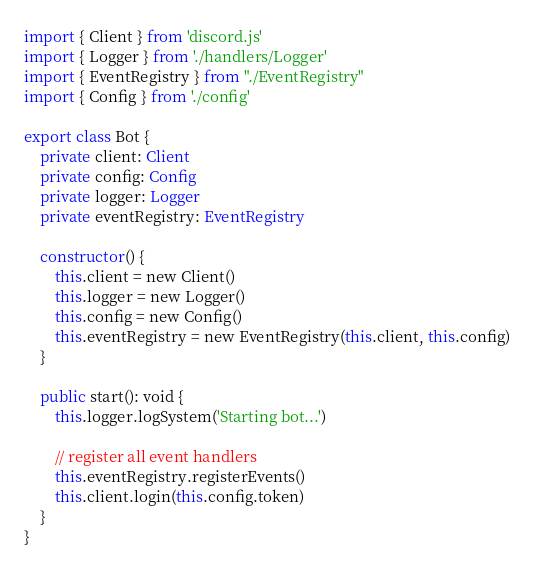Convert code to text. <code><loc_0><loc_0><loc_500><loc_500><_TypeScript_>import { Client } from 'discord.js'
import { Logger } from './handlers/Logger'
import { EventRegistry } from "./EventRegistry"
import { Config } from './config'

export class Bot {
	private client: Client
	private config: Config
	private logger: Logger
	private eventRegistry: EventRegistry

	constructor() {
		this.client = new Client()
		this.logger = new Logger()
		this.config = new Config()
		this.eventRegistry = new EventRegistry(this.client, this.config)
	}

	public start(): void {
		this.logger.logSystem('Starting bot...')
		
		// register all event handlers
		this.eventRegistry.registerEvents()
		this.client.login(this.config.token)
	}
}</code> 